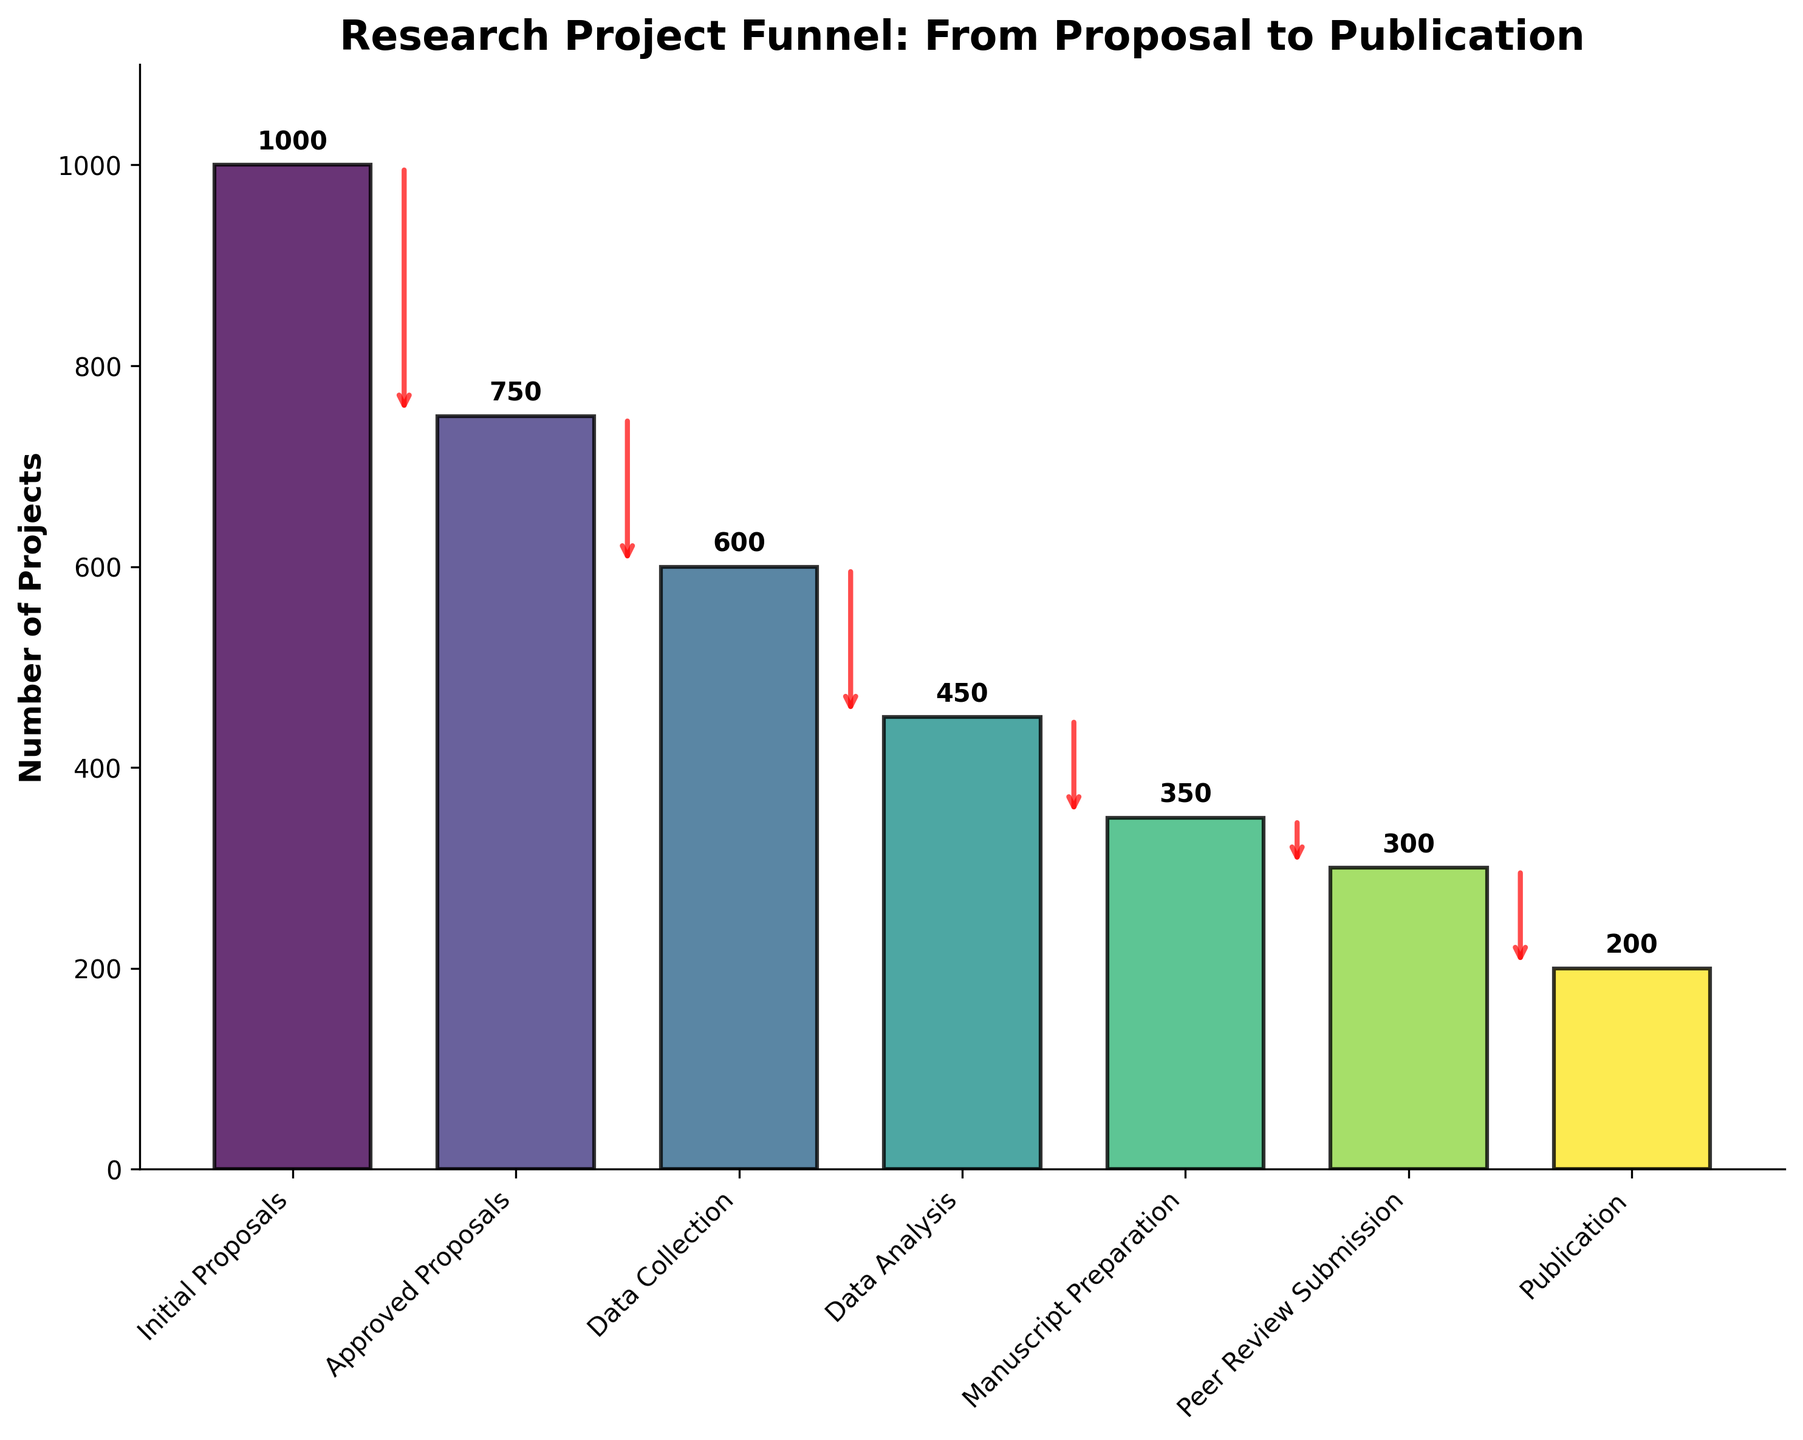What is the title of the figure? The title of a figure is generally found at the top of the chart. It provides a summary of what the chart represents. In this case, it reads "Research Project Funnel: From Proposal to Publication."
Answer: Research Project Funnel: From Proposal to Publication What is the number of projects that reached the Manuscript Preparation stage? Referring to the figure, we observe the bar labeled "Manuscript Preparation," and the number at that level which is displayed above the bar. This number indicates the quantity of projects that reached this stage.
Answer: 350 How many stages are there from proposal to publication in the research project funnel? By counting the labels on the x-axis, one can determine the number of stages represented in the funnel chart. These stages include Initial Proposals, Approved Proposals, Data Collection, Data Analysis, Manuscript Preparation, Peer Review Submission, and Publication.
Answer: 7 What is the attrition rate from Initial Proposals to Approved Proposals? To find the attrition rate, first, determine the number of projects in the Initial Proposals stage (1000) and the number that moved to the Approved Proposals stage (750). The attrition rate is calculated as (Initial Proposals - Approved Proposals) / Initial Proposals * 100. Hence, the calculation is (1000 - 750) / 1000 * 100 = 25%.
Answer: 25% How many more projects reached the Data Analysis stage than the Peer Review Submission stage? To find the difference, identify the number of projects at the Data Analysis stage (450) and at the Peer Review Submission stage (300). Subtracting the latter from the former, we get 450 - 300 = 150.
Answer: 150 What percentage of projects that started Manuscript Preparation were published? First, note the number of projects that reached Manuscript Preparation (350) and the number that reached Publication (200). The percentage is calculated by (Publication / Manuscript Preparation) * 100. Hence, it's (200 / 350) * 100 ≈ 57.14%.
Answer: 57.14% Which stage saw the greatest drop in the number of projects? By examining the lengths of the bars and the arrows between stages, identify the largest decrease. The biggest drop appears from Data Analysis (450) to Manuscript Preparation (350). The drop is 450 - 350 = 100 projects.
Answer: Data Analysis to Manuscript Preparation How many total projects made it through the Data Collection and Data Analysis stages? This question requires adding the number of projects that reached Data Collection (600) and Data Analysis (450). Therefore, the total is 600 + 450 = 1050 projects.
Answer: 1050 Is the number of projects at the Publication stage less than half of those at the Data Collection stage? Compare the number of projects at the Publication stage (200) and half of the projects at the Data Collection stage (600 / 2 = 300). Since 200 is less than 300, the answer is yes.
Answer: Yes 